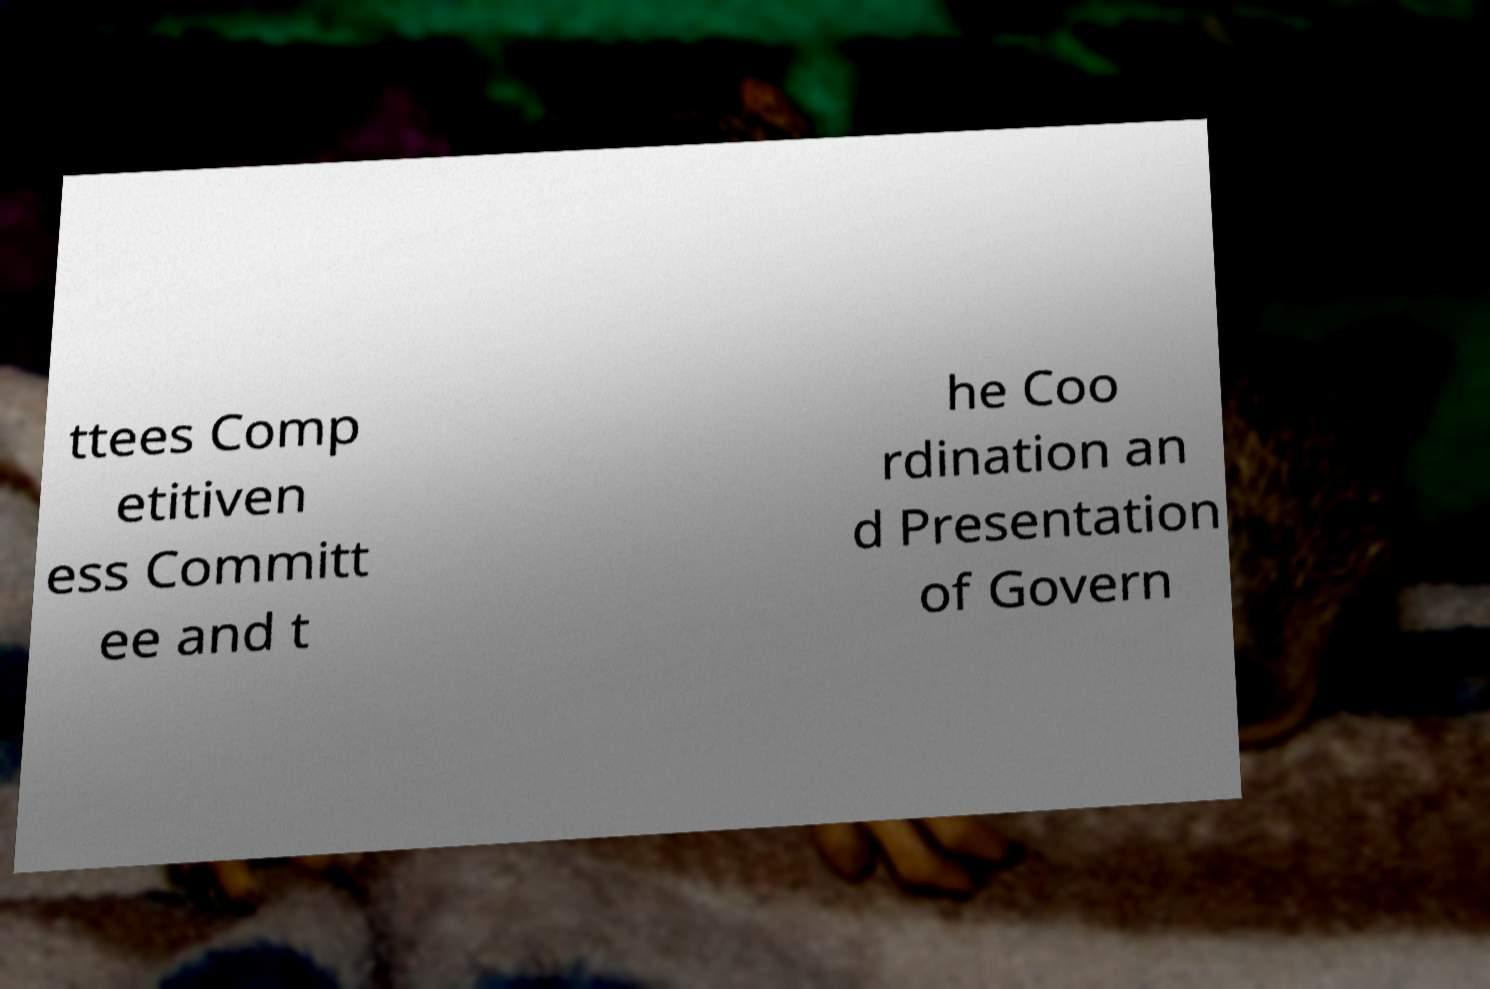Please identify and transcribe the text found in this image. ttees Comp etitiven ess Committ ee and t he Coo rdination an d Presentation of Govern 